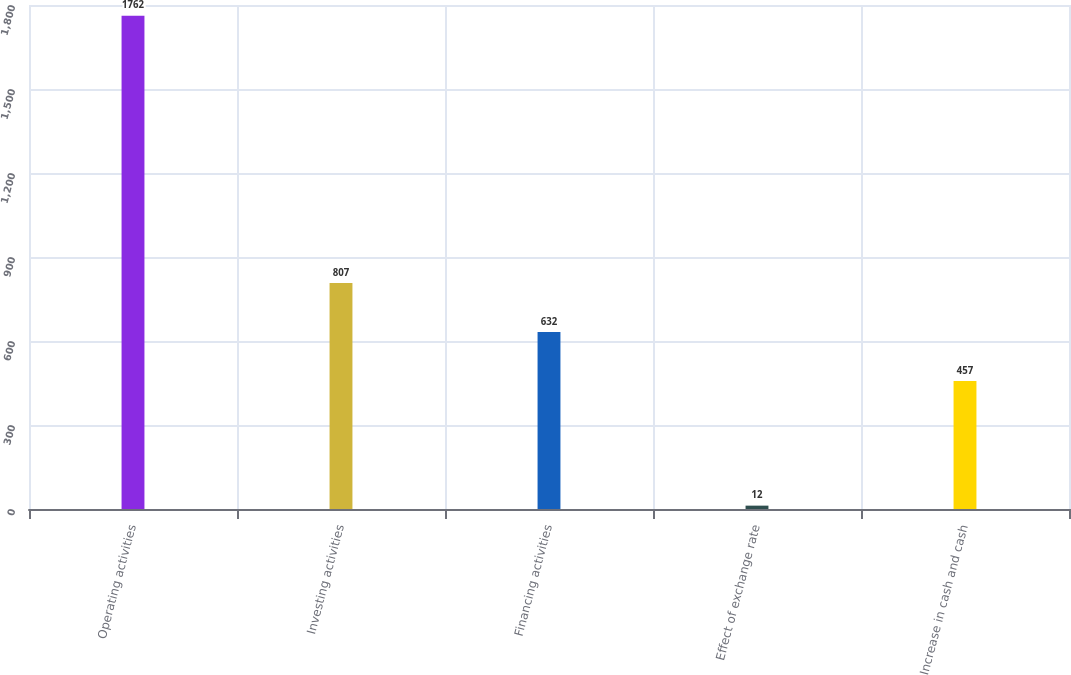<chart> <loc_0><loc_0><loc_500><loc_500><bar_chart><fcel>Operating activities<fcel>Investing activities<fcel>Financing activities<fcel>Effect of exchange rate<fcel>Increase in cash and cash<nl><fcel>1762<fcel>807<fcel>632<fcel>12<fcel>457<nl></chart> 